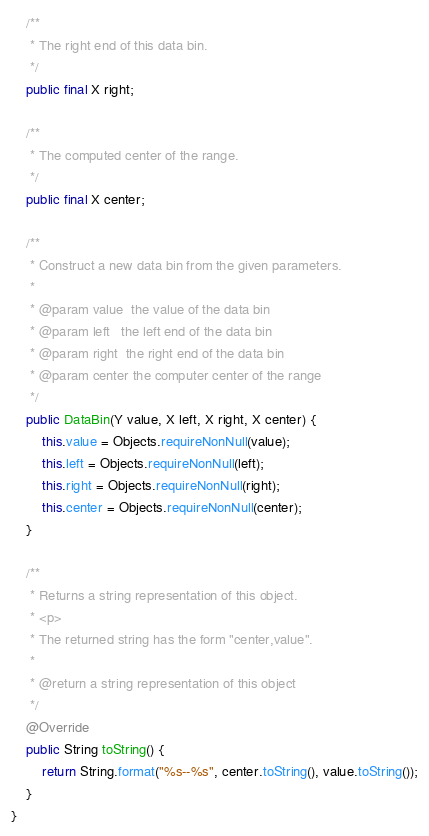<code> <loc_0><loc_0><loc_500><loc_500><_Java_>    /**
     * The right end of this data bin.
     */
    public final X right;

    /**
     * The computed center of the range.
     */
    public final X center;

    /**
     * Construct a new data bin from the given parameters.
     *
     * @param value  the value of the data bin
     * @param left   the left end of the data bin
     * @param right  the right end of the data bin
     * @param center the computer center of the range
     */
    public DataBin(Y value, X left, X right, X center) {
        this.value = Objects.requireNonNull(value);
        this.left = Objects.requireNonNull(left);
        this.right = Objects.requireNonNull(right);
        this.center = Objects.requireNonNull(center);
    }

    /**
     * Returns a string representation of this object.
     * <p>
     * The returned string has the form "center,value".
     *
     * @return a string representation of this object
     */
    @Override
    public String toString() {
        return String.format("%s--%s", center.toString(), value.toString());
    }
}
</code> 